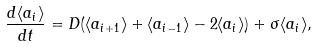Convert formula to latex. <formula><loc_0><loc_0><loc_500><loc_500>\frac { d \langle a _ { i } \rangle } { d t } = D ( \langle a _ { i + 1 } \rangle + \langle a _ { i - 1 } \rangle - 2 \langle a _ { i } \rangle ) + \sigma \langle a _ { i } \rangle ,</formula> 